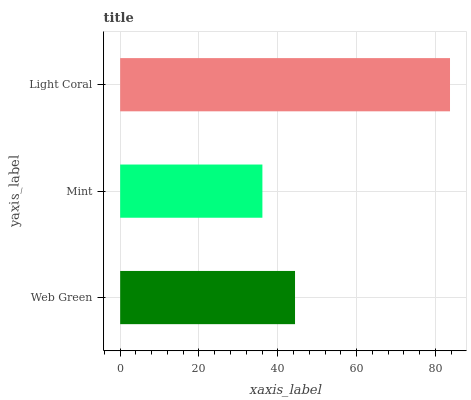Is Mint the minimum?
Answer yes or no. Yes. Is Light Coral the maximum?
Answer yes or no. Yes. Is Light Coral the minimum?
Answer yes or no. No. Is Mint the maximum?
Answer yes or no. No. Is Light Coral greater than Mint?
Answer yes or no. Yes. Is Mint less than Light Coral?
Answer yes or no. Yes. Is Mint greater than Light Coral?
Answer yes or no. No. Is Light Coral less than Mint?
Answer yes or no. No. Is Web Green the high median?
Answer yes or no. Yes. Is Web Green the low median?
Answer yes or no. Yes. Is Light Coral the high median?
Answer yes or no. No. Is Light Coral the low median?
Answer yes or no. No. 